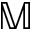Convert formula to latex. <formula><loc_0><loc_0><loc_500><loc_500>\mathbb { M }</formula> 